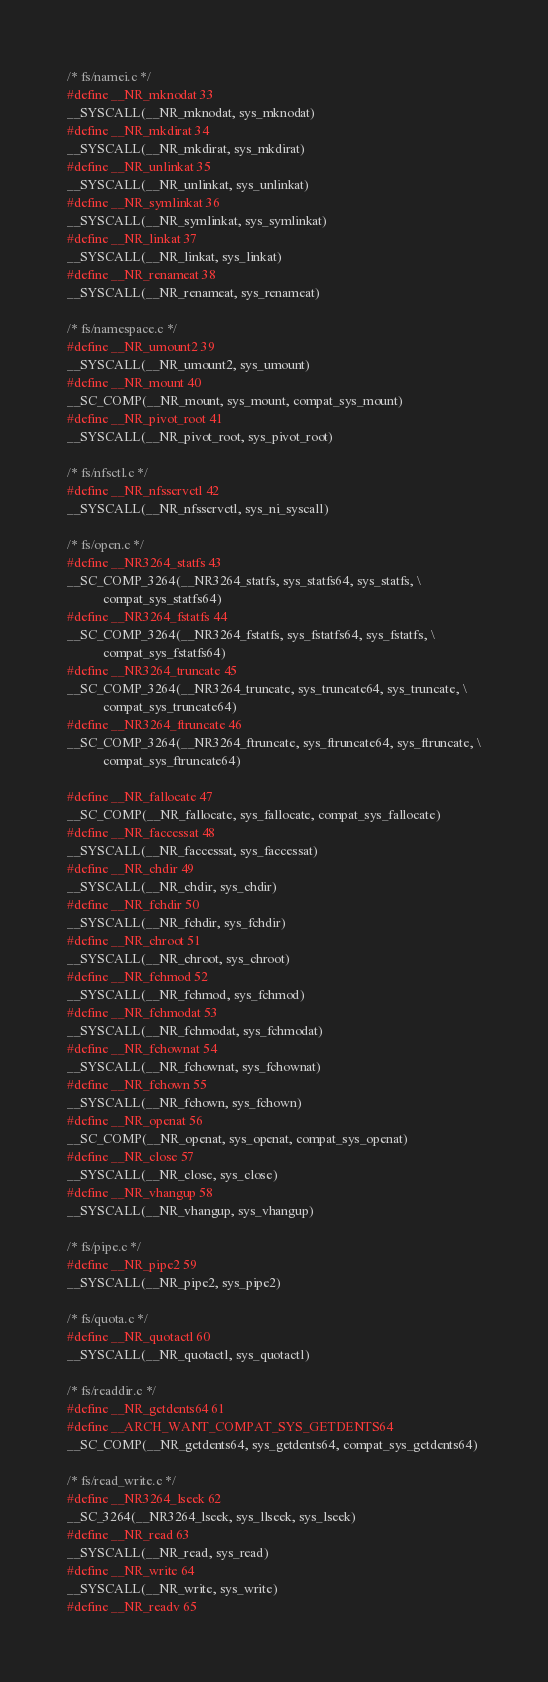<code> <loc_0><loc_0><loc_500><loc_500><_C_>
/* fs/namei.c */
#define __NR_mknodat 33
__SYSCALL(__NR_mknodat, sys_mknodat)
#define __NR_mkdirat 34
__SYSCALL(__NR_mkdirat, sys_mkdirat)
#define __NR_unlinkat 35
__SYSCALL(__NR_unlinkat, sys_unlinkat)
#define __NR_symlinkat 36
__SYSCALL(__NR_symlinkat, sys_symlinkat)
#define __NR_linkat 37
__SYSCALL(__NR_linkat, sys_linkat)
#define __NR_renameat 38
__SYSCALL(__NR_renameat, sys_renameat)

/* fs/namespace.c */
#define __NR_umount2 39
__SYSCALL(__NR_umount2, sys_umount)
#define __NR_mount 40
__SC_COMP(__NR_mount, sys_mount, compat_sys_mount)
#define __NR_pivot_root 41
__SYSCALL(__NR_pivot_root, sys_pivot_root)

/* fs/nfsctl.c */
#define __NR_nfsservctl 42
__SYSCALL(__NR_nfsservctl, sys_ni_syscall)

/* fs/open.c */
#define __NR3264_statfs 43
__SC_COMP_3264(__NR3264_statfs, sys_statfs64, sys_statfs, \
	       compat_sys_statfs64)
#define __NR3264_fstatfs 44
__SC_COMP_3264(__NR3264_fstatfs, sys_fstatfs64, sys_fstatfs, \
	       compat_sys_fstatfs64)
#define __NR3264_truncate 45
__SC_COMP_3264(__NR3264_truncate, sys_truncate64, sys_truncate, \
	       compat_sys_truncate64)
#define __NR3264_ftruncate 46
__SC_COMP_3264(__NR3264_ftruncate, sys_ftruncate64, sys_ftruncate, \
	       compat_sys_ftruncate64)

#define __NR_fallocate 47
__SC_COMP(__NR_fallocate, sys_fallocate, compat_sys_fallocate)
#define __NR_faccessat 48
__SYSCALL(__NR_faccessat, sys_faccessat)
#define __NR_chdir 49
__SYSCALL(__NR_chdir, sys_chdir)
#define __NR_fchdir 50
__SYSCALL(__NR_fchdir, sys_fchdir)
#define __NR_chroot 51
__SYSCALL(__NR_chroot, sys_chroot)
#define __NR_fchmod 52
__SYSCALL(__NR_fchmod, sys_fchmod)
#define __NR_fchmodat 53
__SYSCALL(__NR_fchmodat, sys_fchmodat)
#define __NR_fchownat 54
__SYSCALL(__NR_fchownat, sys_fchownat)
#define __NR_fchown 55
__SYSCALL(__NR_fchown, sys_fchown)
#define __NR_openat 56
__SC_COMP(__NR_openat, sys_openat, compat_sys_openat)
#define __NR_close 57
__SYSCALL(__NR_close, sys_close)
#define __NR_vhangup 58
__SYSCALL(__NR_vhangup, sys_vhangup)

/* fs/pipe.c */
#define __NR_pipe2 59
__SYSCALL(__NR_pipe2, sys_pipe2)

/* fs/quota.c */
#define __NR_quotactl 60
__SYSCALL(__NR_quotactl, sys_quotactl)

/* fs/readdir.c */
#define __NR_getdents64 61
#define __ARCH_WANT_COMPAT_SYS_GETDENTS64
__SC_COMP(__NR_getdents64, sys_getdents64, compat_sys_getdents64)

/* fs/read_write.c */
#define __NR3264_lseek 62
__SC_3264(__NR3264_lseek, sys_llseek, sys_lseek)
#define __NR_read 63
__SYSCALL(__NR_read, sys_read)
#define __NR_write 64
__SYSCALL(__NR_write, sys_write)
#define __NR_readv 65</code> 